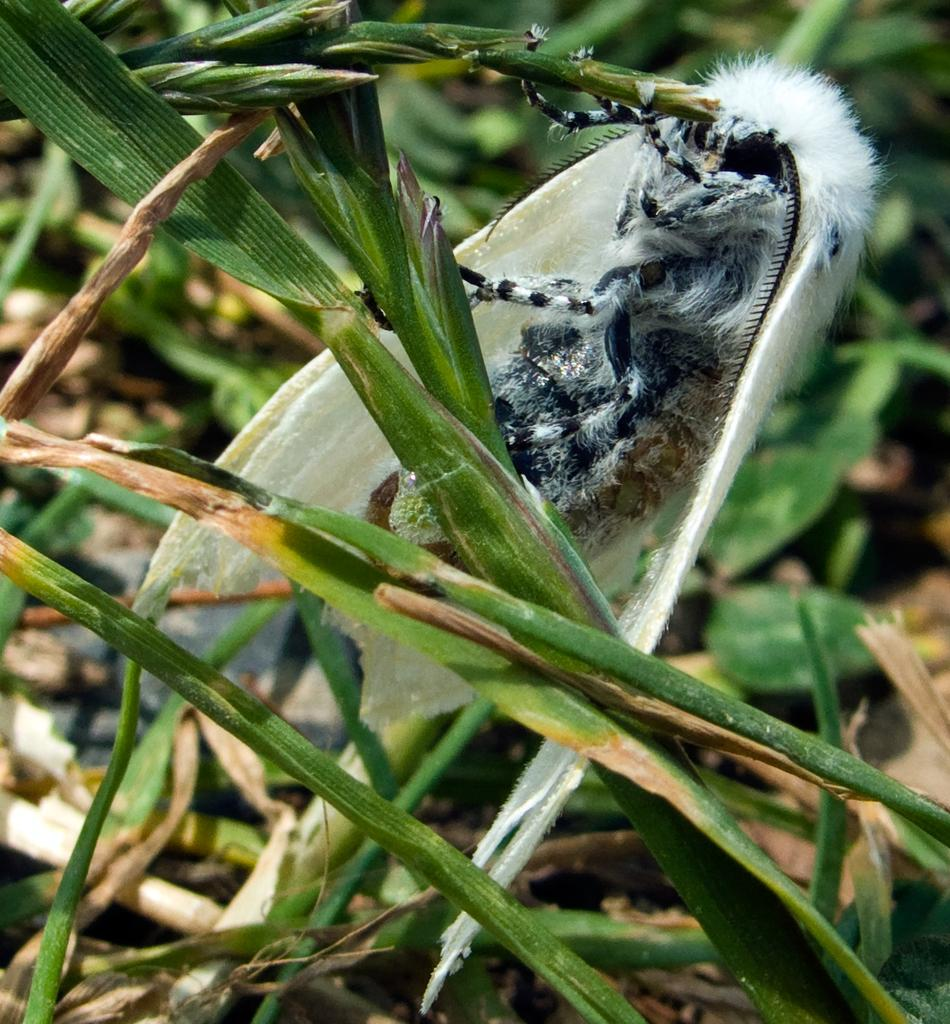What type of insect is present in the image? There is a fly in the image. What is the color of the fly? The fly is white in color. What type of vegetation can be seen on the ground in the image? There is green grass on the ground in the image. What type of plough is being used to cultivate the grass in the image? There is no plough present in the image; it features a white fly and green grass. What is the condition of the grass in the image? The provided facts do not mention the condition of the grass, only its color. 